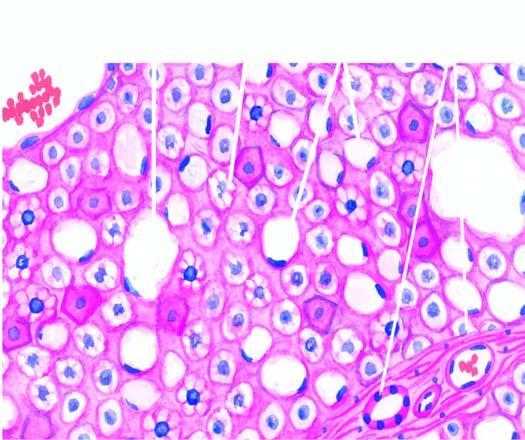do defects in any of the six show multiple small vacuoles in the cytoplasm microvesicles?
Answer the question using a single word or phrase. No 